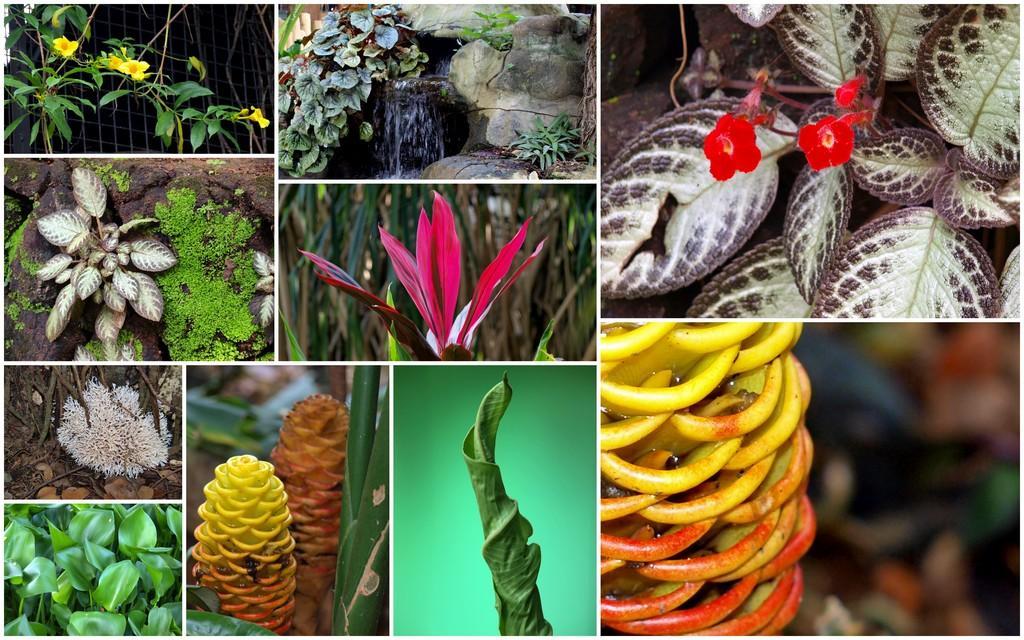Describe this image in one or two sentences. This is a collage. In this picture we can see a few plants and flowers. 